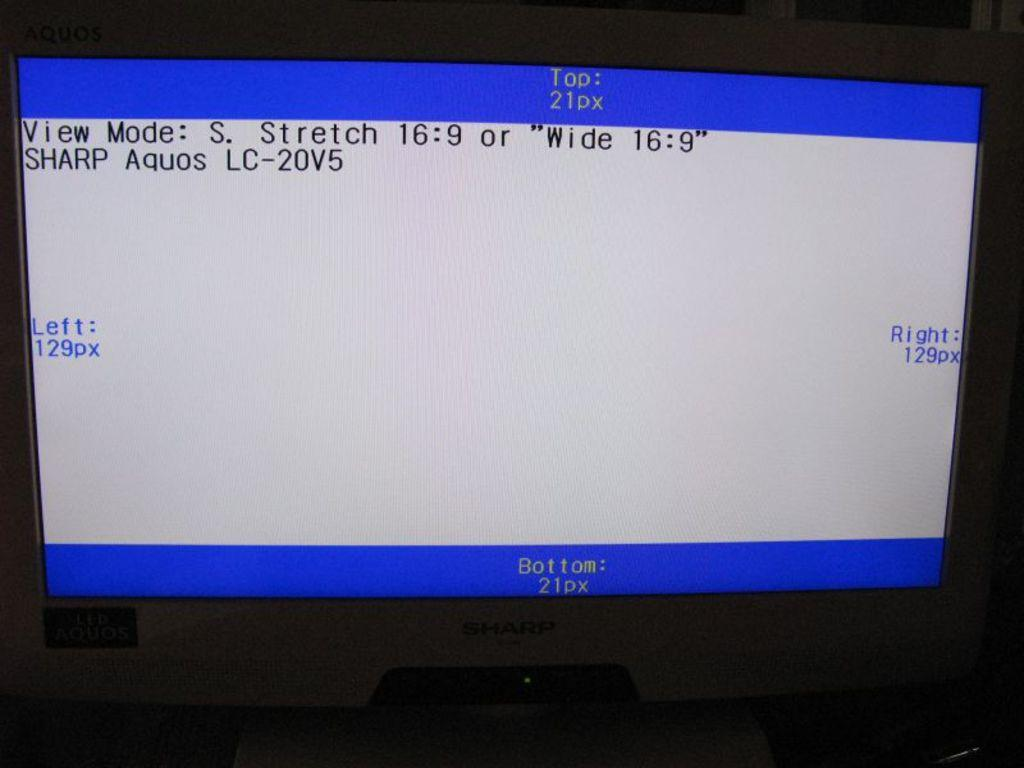<image>
Provide a brief description of the given image. a screen from technology saying View Mode. 